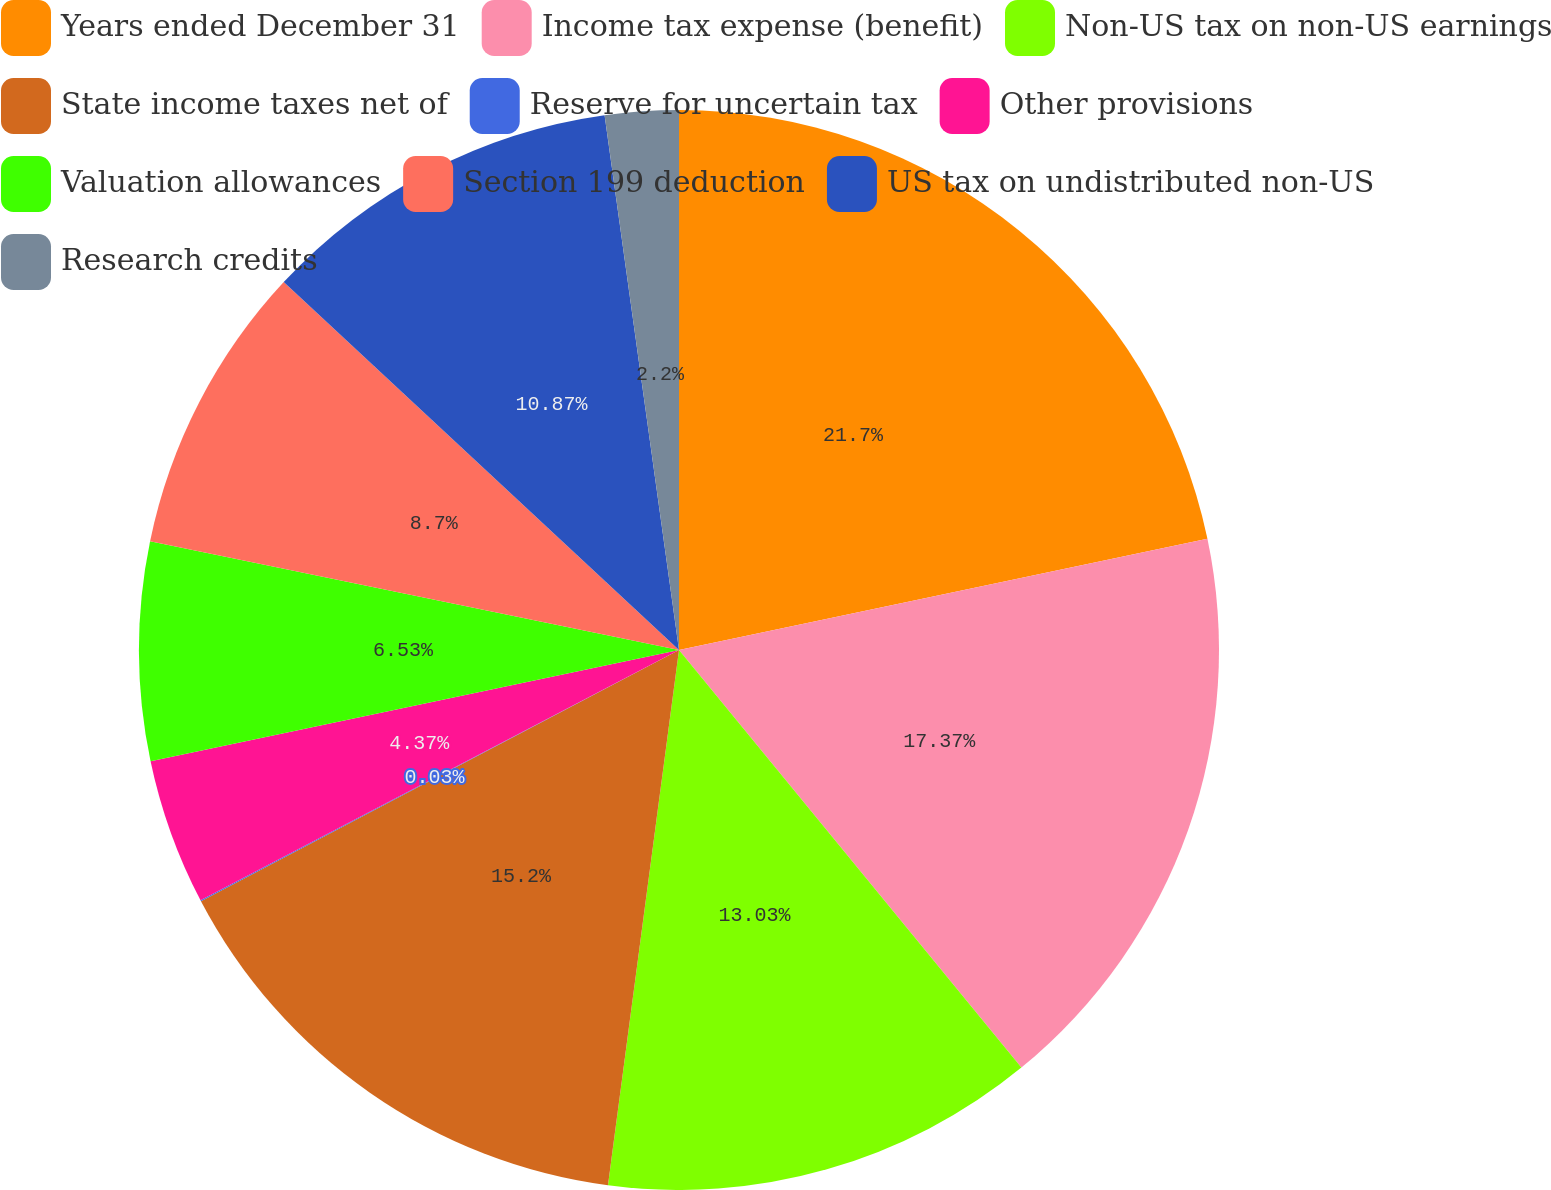<chart> <loc_0><loc_0><loc_500><loc_500><pie_chart><fcel>Years ended December 31<fcel>Income tax expense (benefit)<fcel>Non-US tax on non-US earnings<fcel>State income taxes net of<fcel>Reserve for uncertain tax<fcel>Other provisions<fcel>Valuation allowances<fcel>Section 199 deduction<fcel>US tax on undistributed non-US<fcel>Research credits<nl><fcel>21.7%<fcel>17.37%<fcel>13.03%<fcel>15.2%<fcel>0.03%<fcel>4.37%<fcel>6.53%<fcel>8.7%<fcel>10.87%<fcel>2.2%<nl></chart> 